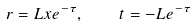Convert formula to latex. <formula><loc_0><loc_0><loc_500><loc_500>r = L x e ^ { - \tau } , \quad t = - L e ^ { - \tau }</formula> 